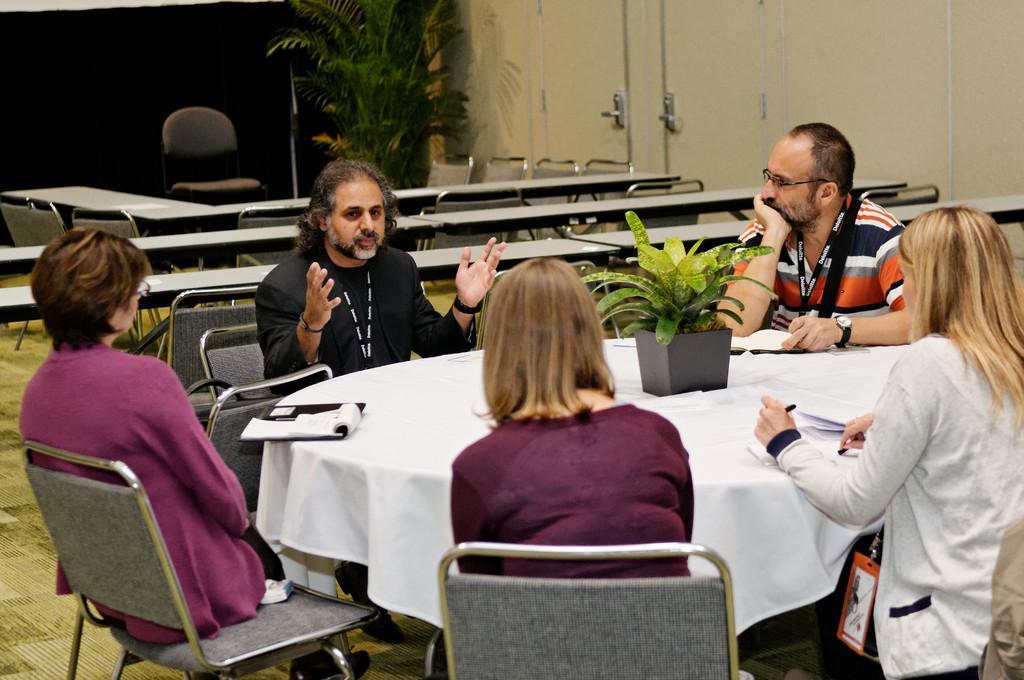Could you give a brief overview of what you see in this image? This picture shows a group of people seated on the chair and a man speaking and we see a plant on the table and we see a book and we see few chairs and tables on the side and we see a plant on the corner of the room 